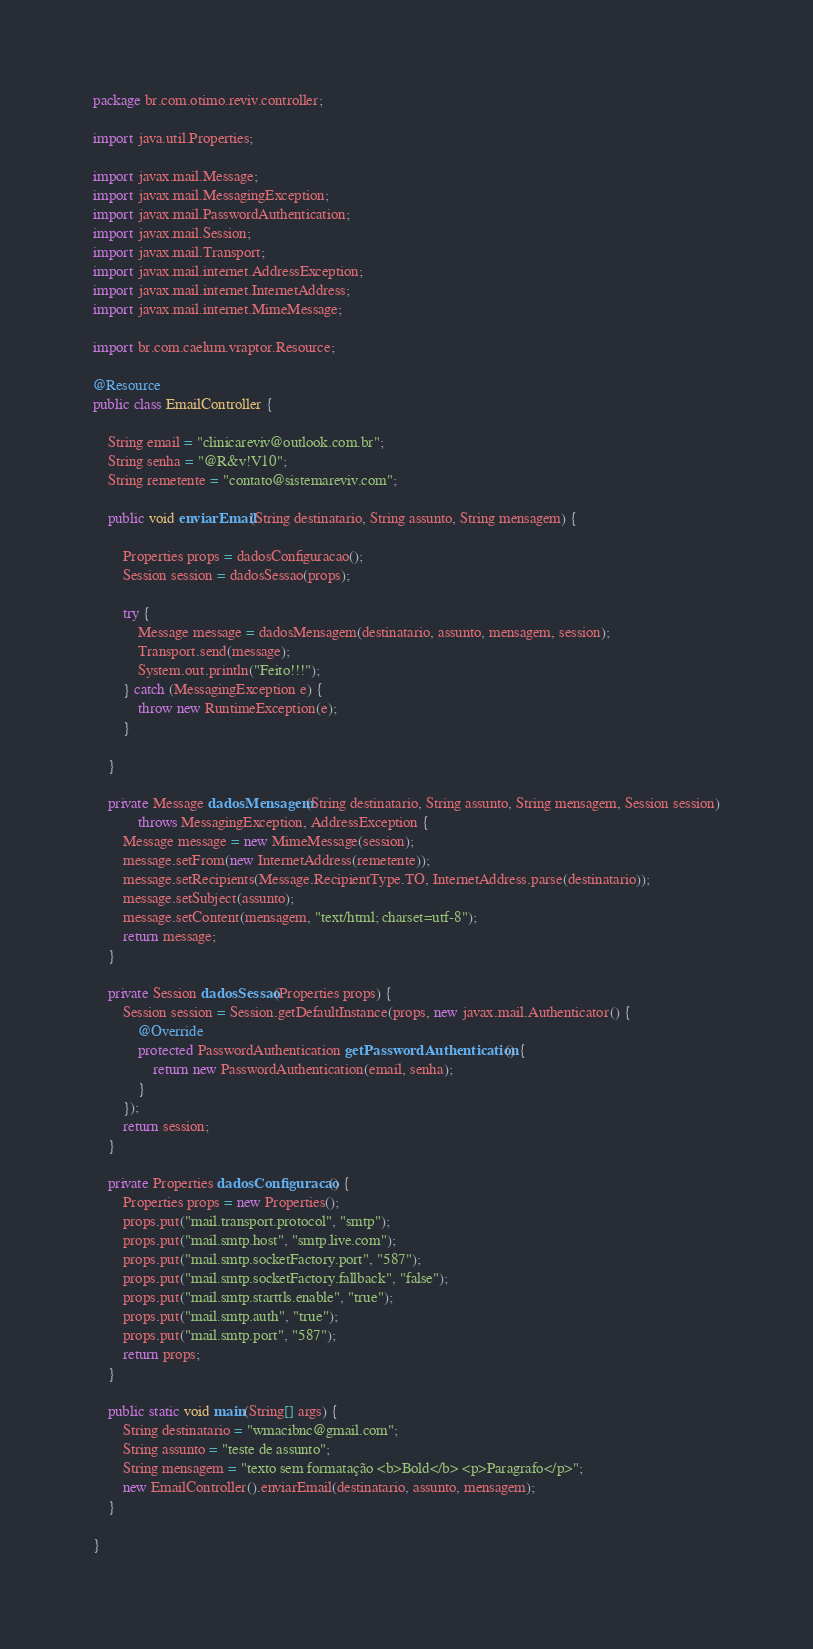<code> <loc_0><loc_0><loc_500><loc_500><_Java_>package br.com.otimo.reviv.controller;

import java.util.Properties;

import javax.mail.Message;
import javax.mail.MessagingException;
import javax.mail.PasswordAuthentication;
import javax.mail.Session;
import javax.mail.Transport;
import javax.mail.internet.AddressException;
import javax.mail.internet.InternetAddress;
import javax.mail.internet.MimeMessage;

import br.com.caelum.vraptor.Resource;

@Resource
public class EmailController {

	String email = "clinicareviv@outlook.com.br";
	String senha = "@R&v!V10";
	String remetente = "contato@sistemareviv.com";

	public void enviarEmail(String destinatario, String assunto, String mensagem) {

		Properties props = dadosConfiguracao();
		Session session = dadosSessao(props);

		try {
			Message message = dadosMensagem(destinatario, assunto, mensagem, session);
			Transport.send(message);
			System.out.println("Feito!!!");
		} catch (MessagingException e) {
			throw new RuntimeException(e);
		}

	}

	private Message dadosMensagem(String destinatario, String assunto, String mensagem, Session session)
			throws MessagingException, AddressException {
		Message message = new MimeMessage(session);
		message.setFrom(new InternetAddress(remetente));
		message.setRecipients(Message.RecipientType.TO, InternetAddress.parse(destinatario));
		message.setSubject(assunto);
		message.setContent(mensagem, "text/html; charset=utf-8");
		return message;
	}

	private Session dadosSessao(Properties props) {
		Session session = Session.getDefaultInstance(props, new javax.mail.Authenticator() {
			@Override
			protected PasswordAuthentication getPasswordAuthentication() {
				return new PasswordAuthentication(email, senha);
			}
		});
		return session;
	}

	private Properties dadosConfiguracao() {
		Properties props = new Properties();
		props.put("mail.transport.protocol", "smtp");
		props.put("mail.smtp.host", "smtp.live.com");
		props.put("mail.smtp.socketFactory.port", "587");
		props.put("mail.smtp.socketFactory.fallback", "false");
		props.put("mail.smtp.starttls.enable", "true");
		props.put("mail.smtp.auth", "true");
		props.put("mail.smtp.port", "587");
		return props;
	}

	public static void main(String[] args) {
		String destinatario = "wmacibnc@gmail.com";
		String assunto = "teste de assunto";
		String mensagem = "texto sem formatação <b>Bold</b> <p>Paragrafo</p>";
		new EmailController().enviarEmail(destinatario, assunto, mensagem);
	}

}
</code> 